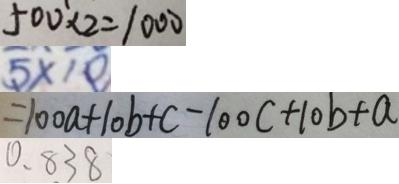Convert formula to latex. <formula><loc_0><loc_0><loc_500><loc_500>5 0 0 \times 2 = 1 0 0 
 5 \times 1 0 
 = 1 0 0 a + 1 0 b + c - 1 0 0 c + 1 0 b + a 
 0 . 8 3 8</formula> 